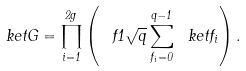Convert formula to latex. <formula><loc_0><loc_0><loc_500><loc_500>\ k e t G = \prod _ { i = 1 } ^ { 2 g } \left ( \ f { 1 } { \sqrt { q } } \sum _ { f _ { i } = 0 } ^ { q - 1 } \ k e t f _ { i } \right ) .</formula> 